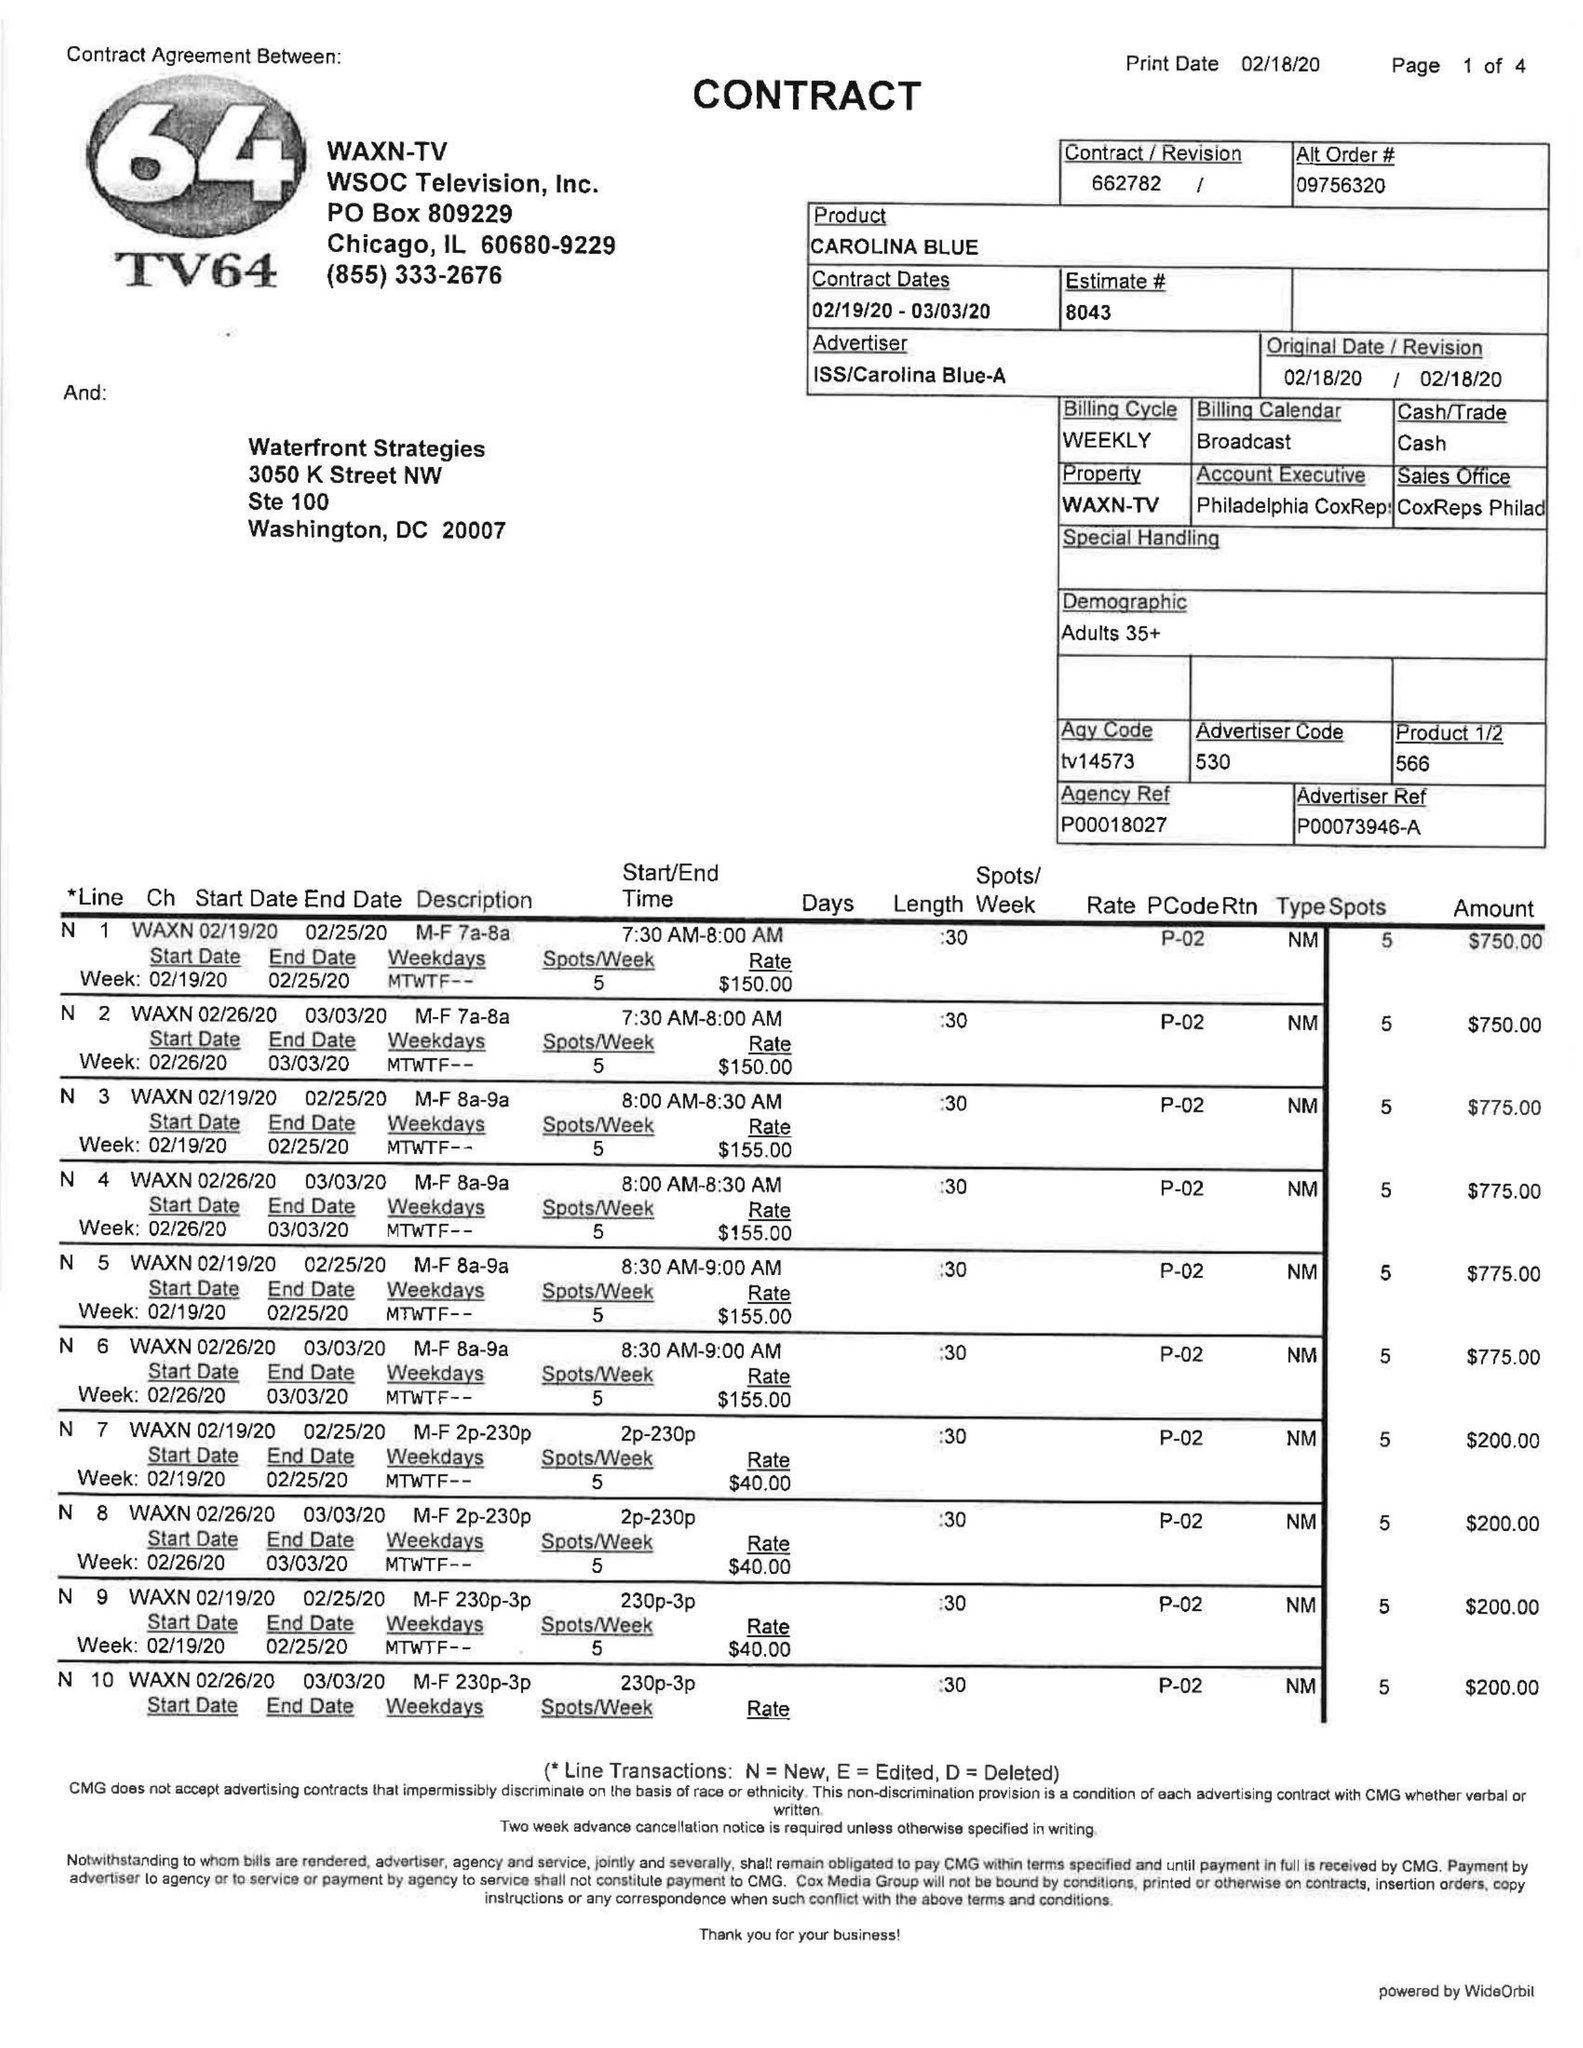What is the value for the flight_from?
Answer the question using a single word or phrase. 02/19/20 